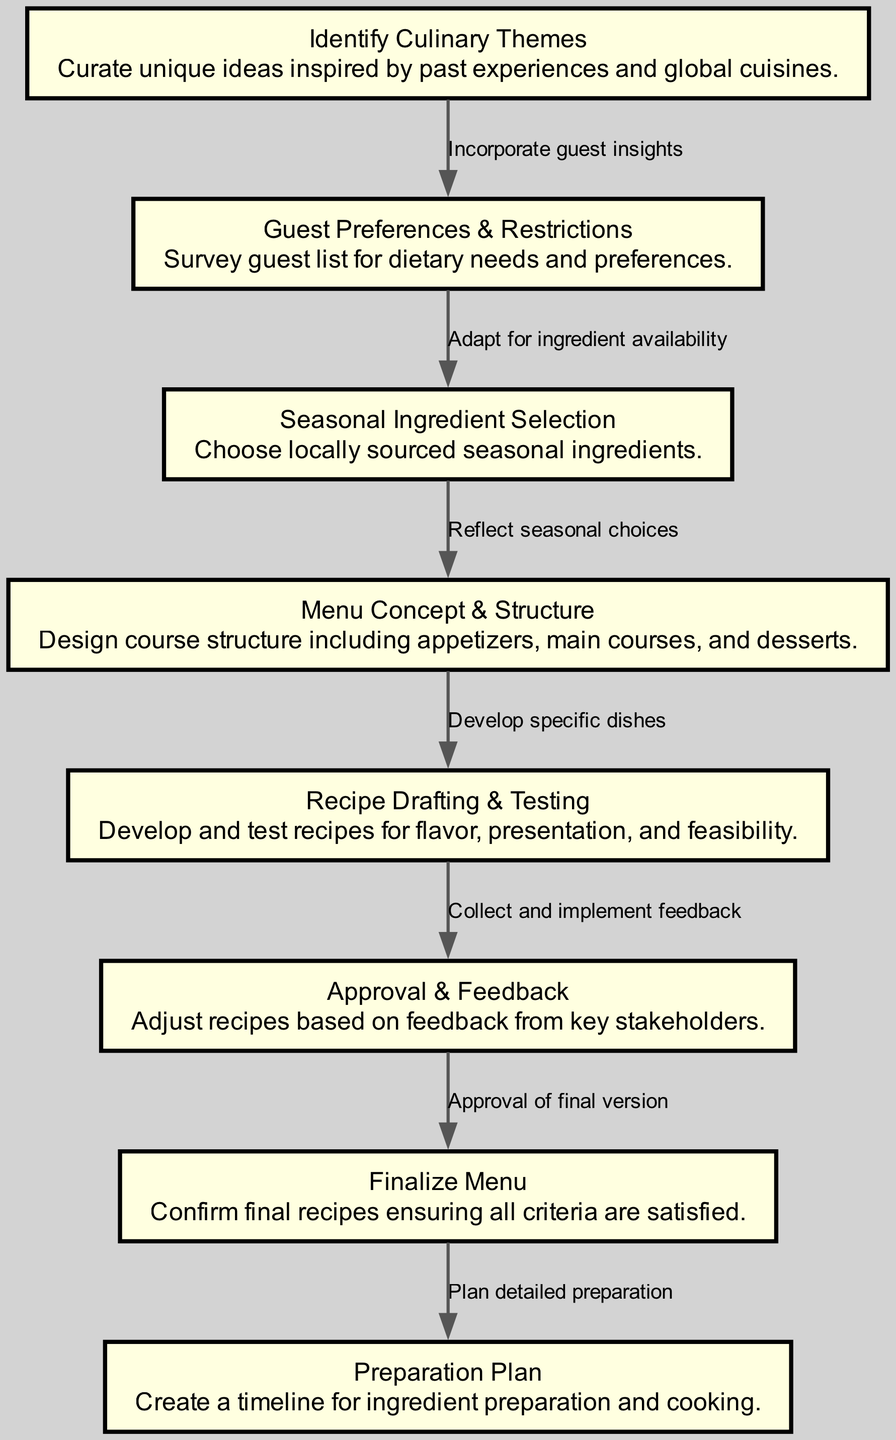What is the first step in the recipe development flowchart? The first node in the diagram is labeled "Identify Culinary Themes," which initiates the process of developing the wedding menu.
Answer: Identify Culinary Themes How many nodes are in the diagram? By counting the nodes listed in the data, we find there are eight distinct nodes in the recipe development flowchart.
Answer: 8 What step follows "Approval & Feedback"? The diagram shows that after "Approval & Feedback," the next step in the flow is "Finalize Menu," indicating it is the subsequent action to take.
Answer: Finalize Menu What is the relationship between "Guest Preferences & Restrictions" and "Seasonal Ingredient Selection"? The flowchart indicates that "Guest Preferences & Restrictions" leads to "Seasonal Ingredient Selection," demonstrating a direct adaptation to ingredient availability based on guest preferences.
Answer: Adapt for ingredient availability Which step involves gathering input from stakeholders? The node "Approval & Feedback" specifically mentions collecting and implementing feedback, thus involving the process of gathering insights from key stakeholders.
Answer: Approval & Feedback What is the last step before creating a preparation plan? Before the "Preparation Plan" is initiated, the flowchart clearly shows that the last step taken is "Finalize Menu," confirming that it is the prior action completed.
Answer: Finalize Menu What do you do after "Recipe Drafting & Testing"? The next action specified in the flowchart after "Recipe Drafting & Testing" is "Approval & Feedback," indicating that feedback and approvals follow the testing phase.
Answer: Approval & Feedback What are the elements included in the "Menu Concept & Structure"? The description of this node indicates that it designs the course structure, specifically mentioning appetizers, main courses, and desserts.
Answer: Appetizers, main courses, and desserts 